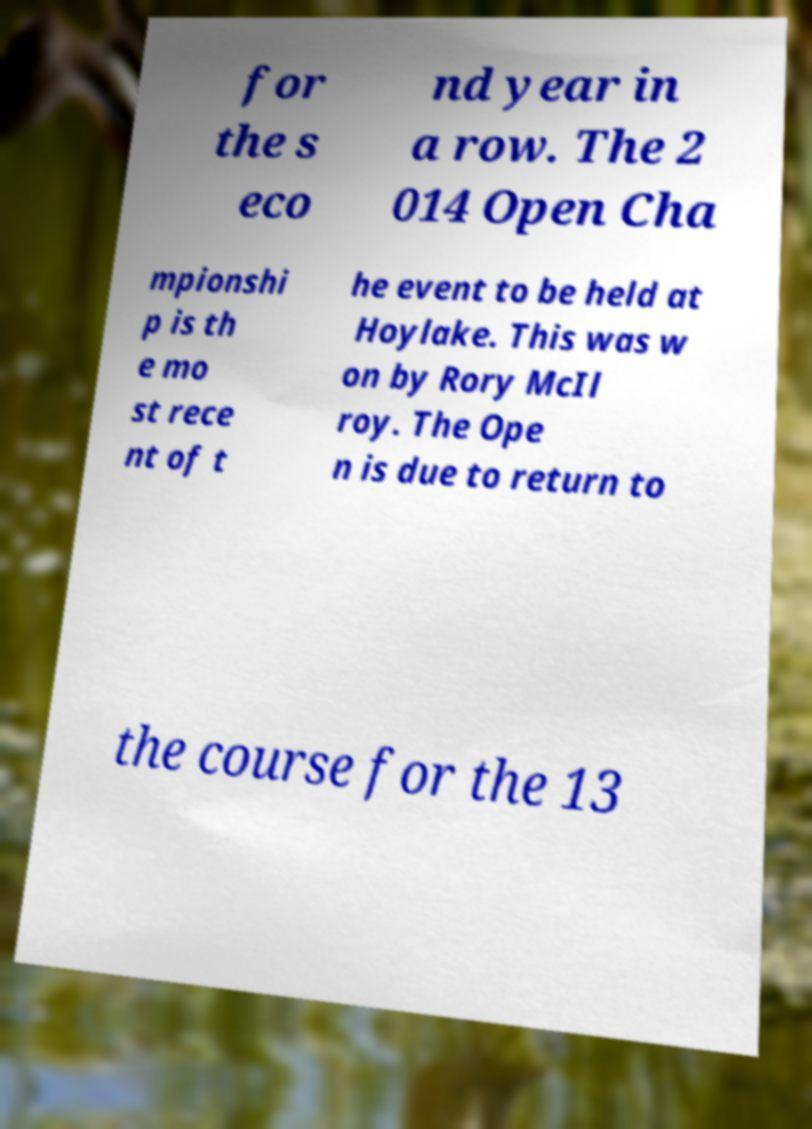There's text embedded in this image that I need extracted. Can you transcribe it verbatim? for the s eco nd year in a row. The 2 014 Open Cha mpionshi p is th e mo st rece nt of t he event to be held at Hoylake. This was w on by Rory McIl roy. The Ope n is due to return to the course for the 13 